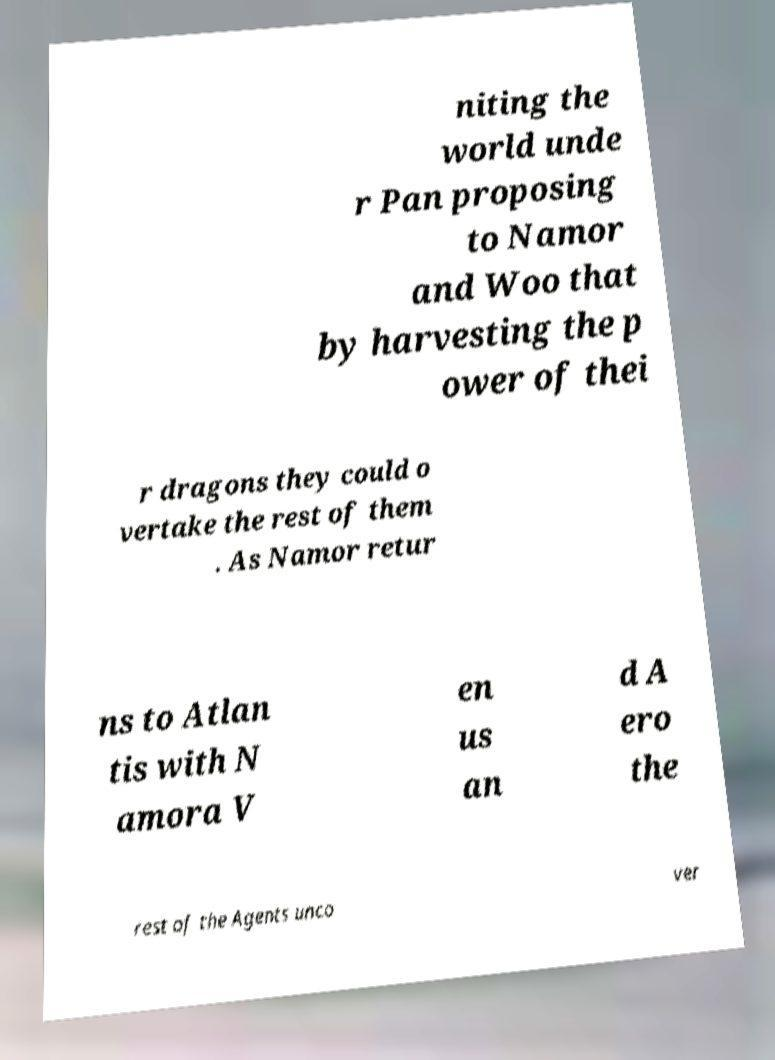Can you read and provide the text displayed in the image?This photo seems to have some interesting text. Can you extract and type it out for me? niting the world unde r Pan proposing to Namor and Woo that by harvesting the p ower of thei r dragons they could o vertake the rest of them . As Namor retur ns to Atlan tis with N amora V en us an d A ero the rest of the Agents unco ver 